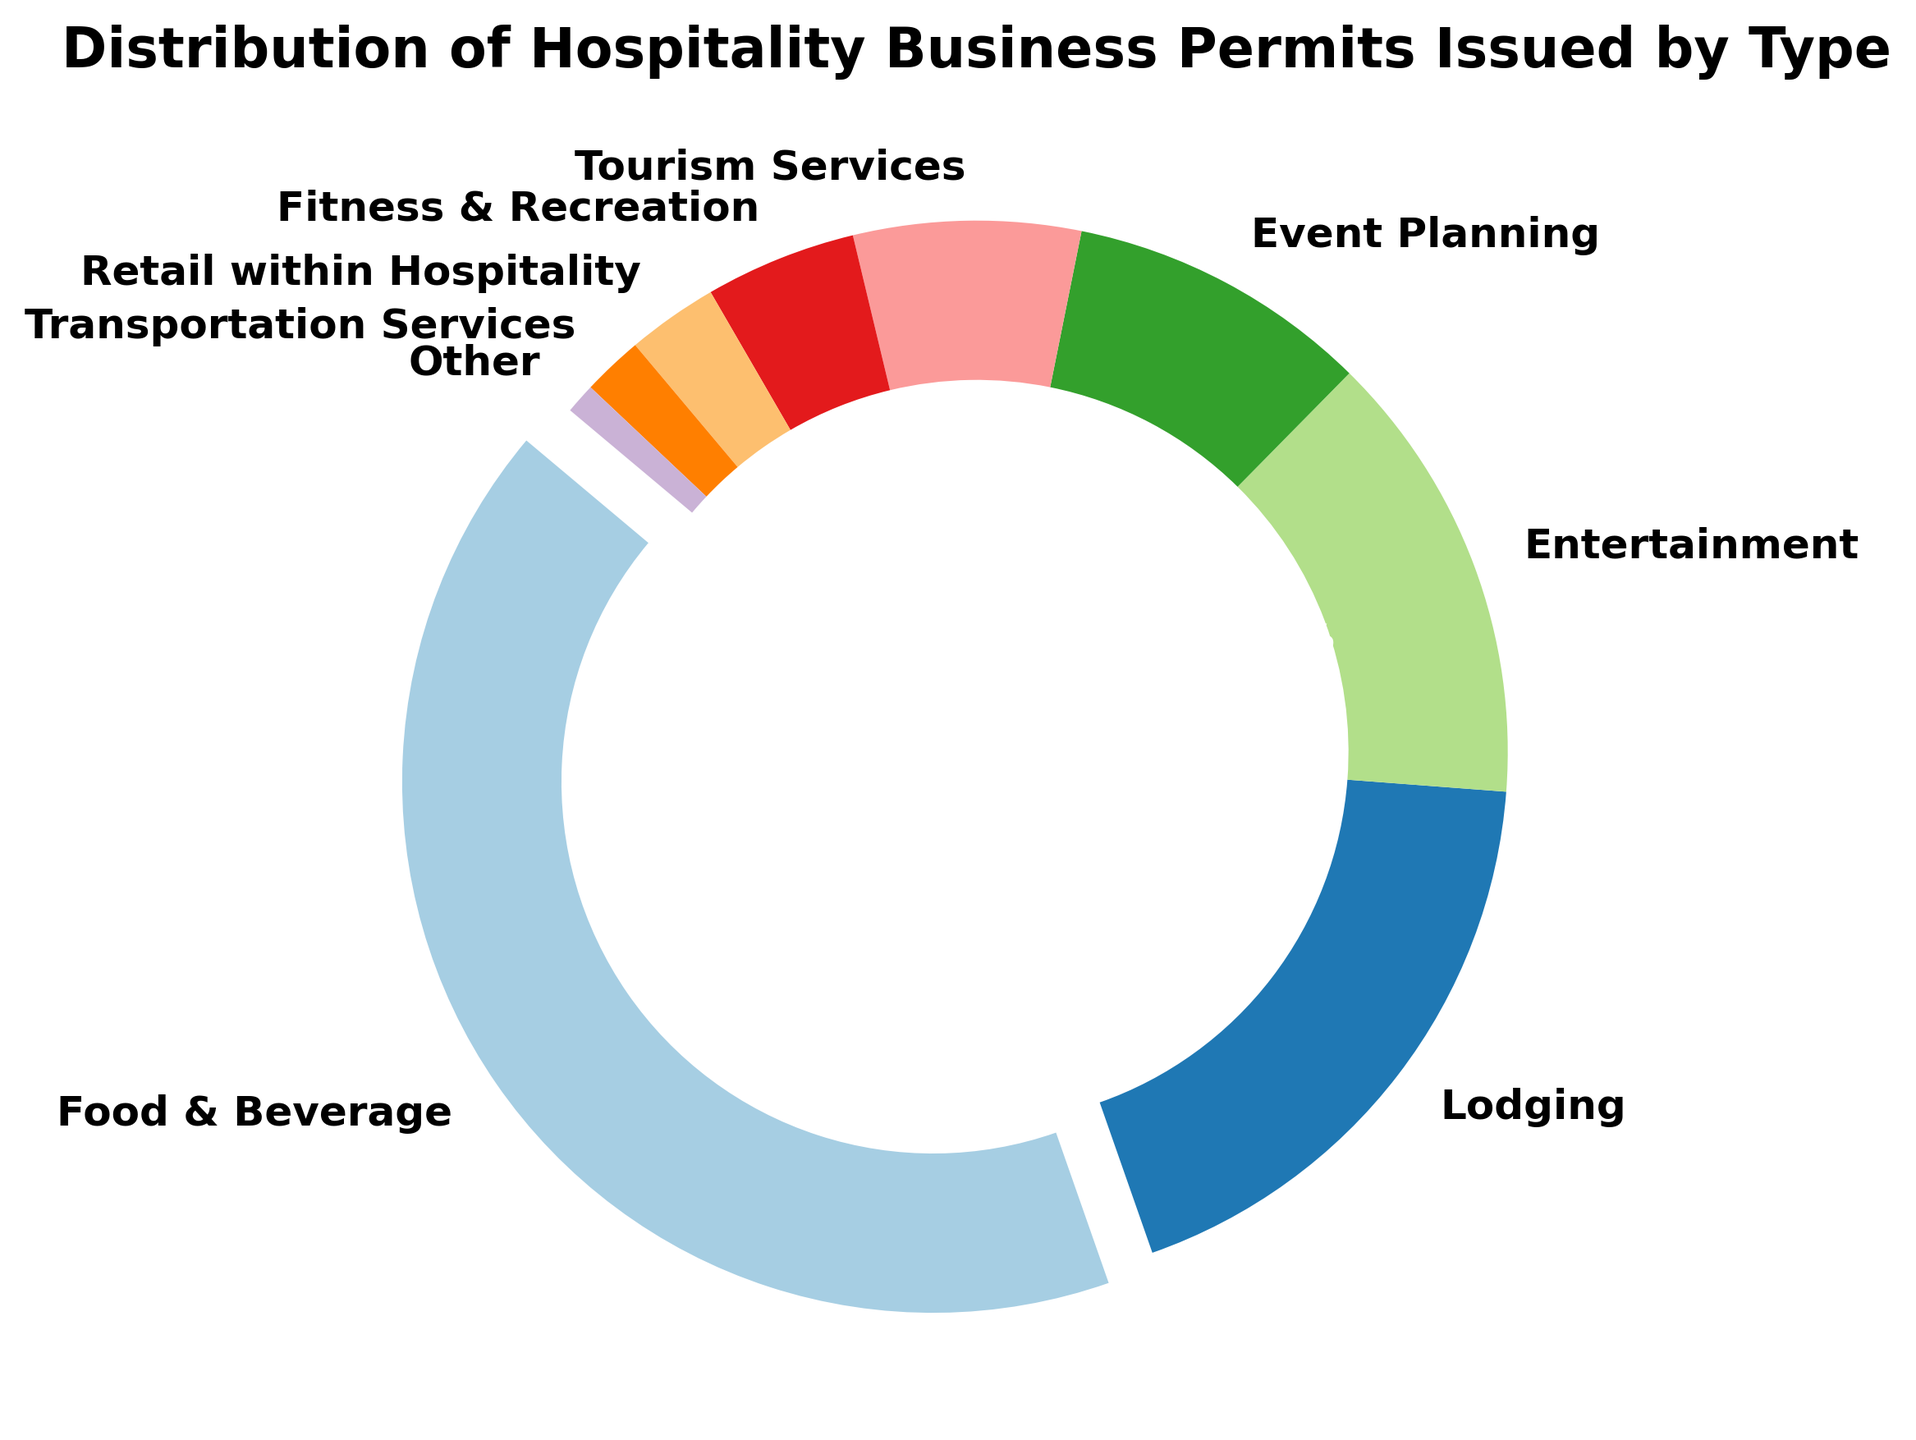What's the largest category of permits issued? The largest category visually stands out due to its size and the fact that its wedge is slightly separated from the rest. By observing the figure, the segment labeled "Food & Beverage" is the largest.
Answer: Food & Beverage How many more permits were issued for Lodging compared to Entertainment? From the figure, we can see the count for Lodging is 2000 and for Entertainment is 1500. Subtracting these two numbers gives the difference. 2000 - 1500 = 500
Answer: 500 Which types of permits together make up around half of the total permits issued? By examining the sizes of the segments, Food & Beverage (4500) and Lodging (2000) are significantly large. Adding their counts: 4500 + 2000 = 6500. The total number of permits is 10750. Therefore, these two combined make 6500 out of 10750 which is around 60%, thus they make up a significant portion.
Answer: Food & Beverage and Lodging What is the smallest category of permits issued? The smallest wedge is visually the thinnest segment. Labeling shows "Other" is the smallest segment on the figure.
Answer: Other If we combine the permits for Fitness & Recreation and Retail within Hospitality, what percentage of the total does this combination represent? The counts are 500 for Fitness & Recreation and 300 for Retail within Hospitality. Their sum is 800. The total number of permits is 10750. The percentage is calculated as (800/10750) * 100 = approximately 7.4%.
Answer: 7.4% Compare the number of permits issued for Entertainment to the combination of Event Planning and Tourism Services. Which is larger, and by how much? Event Planning has 1000 permits and Tourism Services has 750 permits, their sum is 1750. Entertainment has 1500 permits. 1750 - 1500 = 250 more permits were issued for the combination.
Answer: Combination of Event Planning and Tourism Services, by 250 What's the combined percentage of the smallest three categories? Adding the counts for Other (100), Transportation Services (200), and Retail within Hospitality (300) gives 600. The total permits are 10750. The combined percentage is (600/10750) * 100 ≈ 5.6%.
Answer: 5.6% Which category has roughly half the permits compared to Food & Beverage? Food & Beverage has 4500 permits. Lodging which has 2000 permits, visually it's close to half but next highest is Event Planning & Tourism which combined will not come close, similarly Fitness & Recreation and below do not form 50%.
Answer: Lodging How does the number of permits for Fitness & Recreation compare to that for Transportation Services, and by what factor is it larger? Fitness & Recreation has 500 permits and Transportation Services has 200 permits. The factor is calculated as 500/200 = 2.5. So, Fitness & Recreation permits are 2.5 times those for Transportation Services.
Answer: 2.5 times 